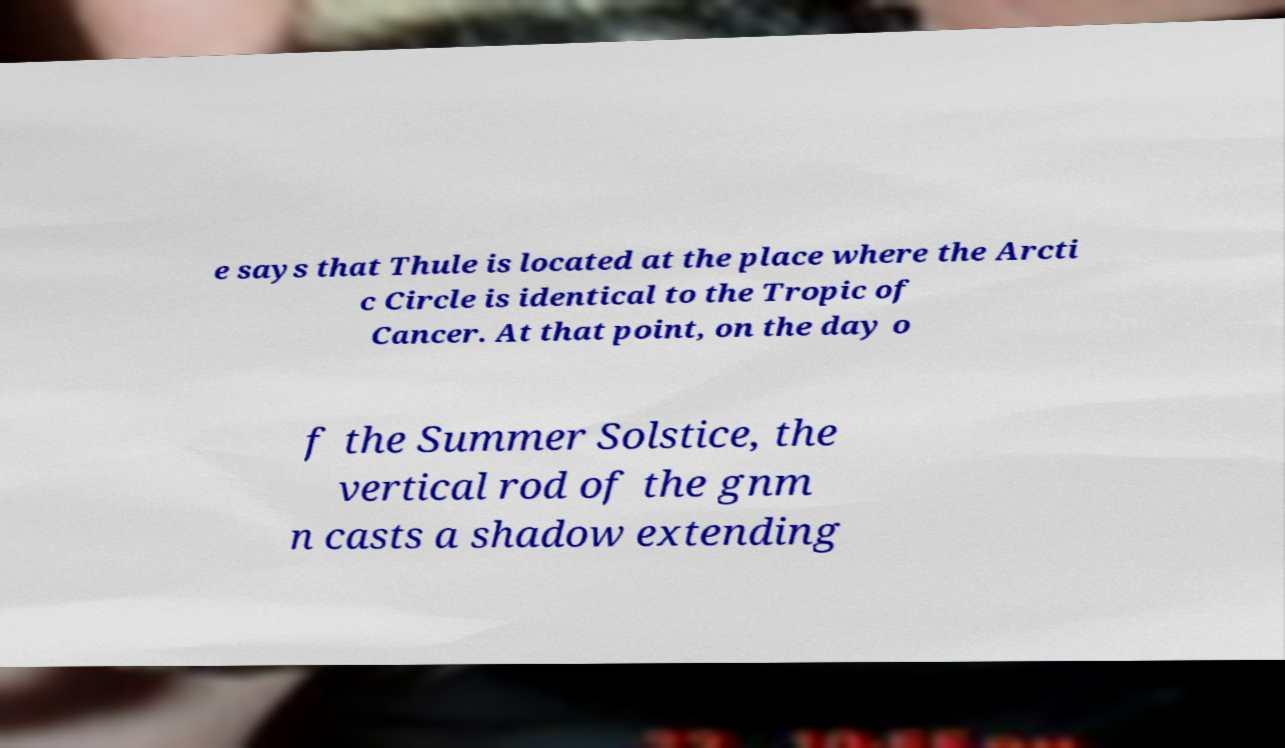I need the written content from this picture converted into text. Can you do that? e says that Thule is located at the place where the Arcti c Circle is identical to the Tropic of Cancer. At that point, on the day o f the Summer Solstice, the vertical rod of the gnm n casts a shadow extending 